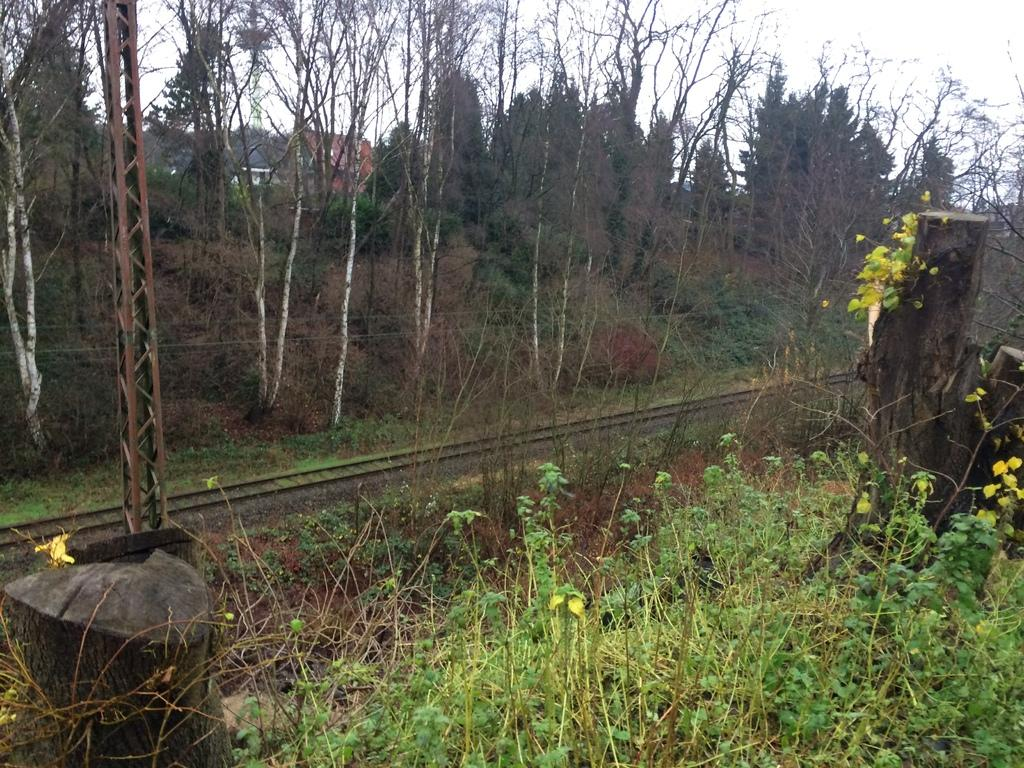What type of transportation infrastructure is visible in the image? There is a train track in the image. What other objects can be seen in the image? There is a pole, grass, a plant, a tree trunk, trees, a building, and the sky visible in the image. Can you describe the vegetation in the image? There is grass, a plant, and trees in the image. What type of structure is present in the image? There is a building in the image. What part of the natural environment is visible in the image? The sky is visible in the image. What time of day is it in the image, and how does the afternoon affect the train's schedule? The time of day is not mentioned in the image, and there is no information about the train's schedule. Additionally, the image does not depict a train, only a train track. 